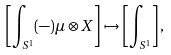Convert formula to latex. <formula><loc_0><loc_0><loc_500><loc_500>\left [ \int _ { S ^ { 1 } } ( - ) \mu \otimes X \right ] \mapsto \left [ \int _ { S ^ { 1 } } \right ] ,</formula> 